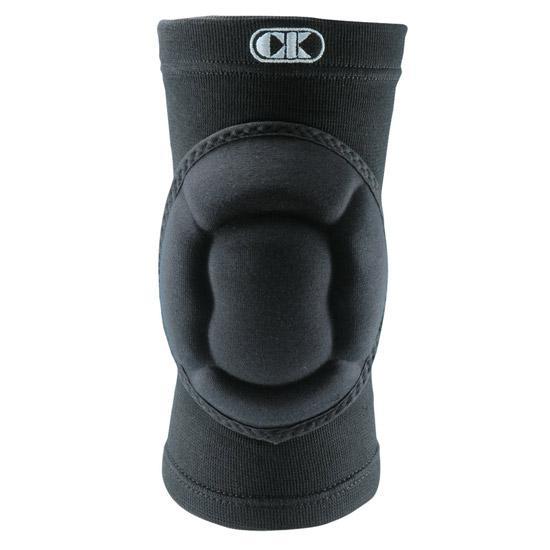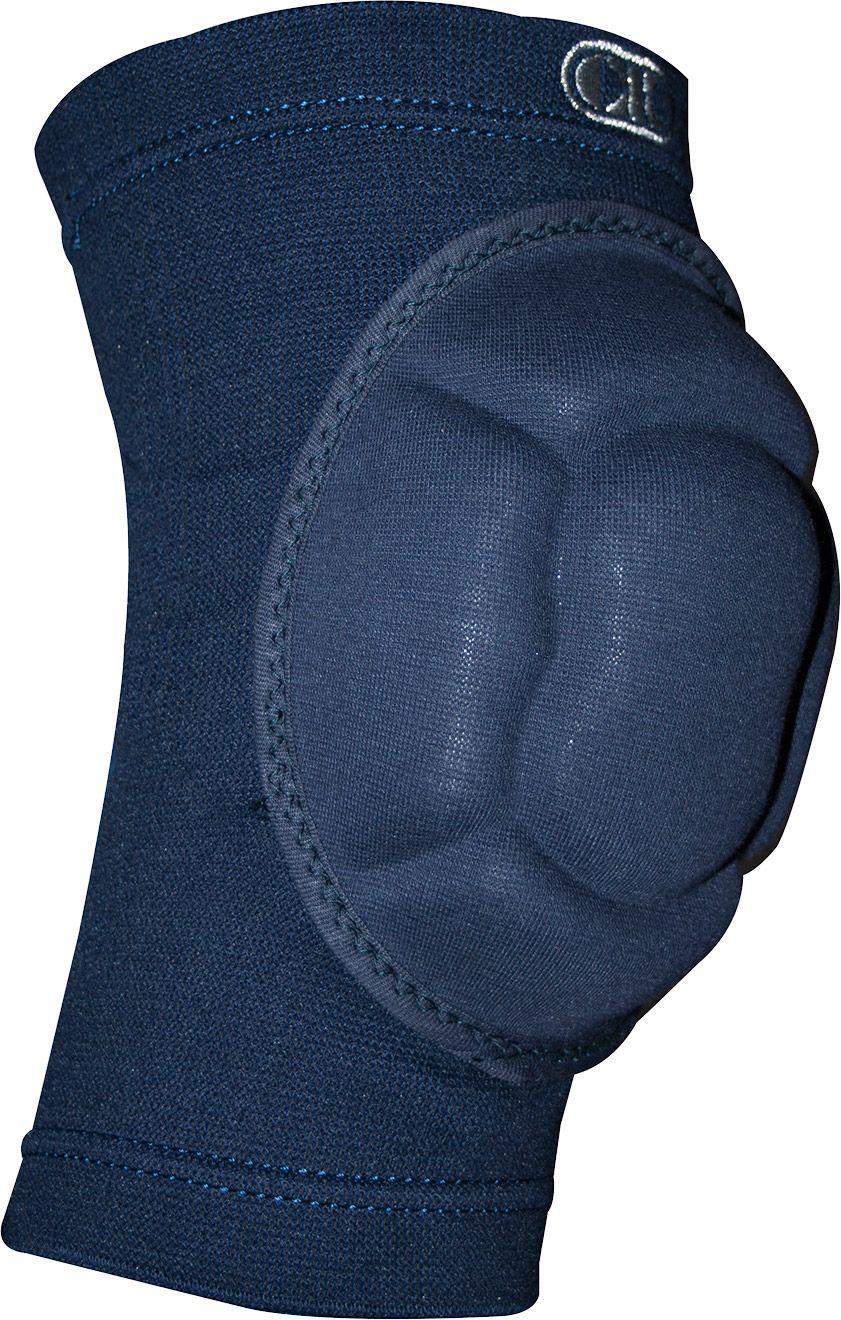The first image is the image on the left, the second image is the image on the right. Considering the images on both sides, is "There are two kneepads in total" valid? Answer yes or no. Yes. 